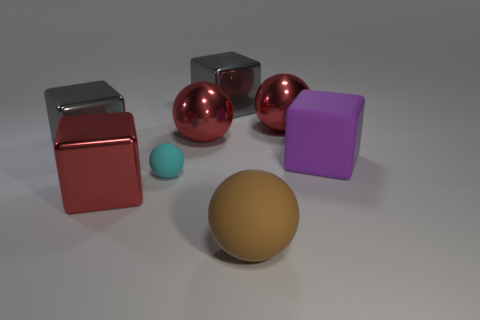What material is the purple cube that is the same size as the brown sphere?
Give a very brief answer. Rubber. The big metallic thing in front of the purple matte object is what color?
Your answer should be very brief. Red. How many metal cylinders are there?
Offer a terse response. 0. Is there a red object left of the brown ball to the right of the large red metal object that is in front of the big purple rubber block?
Offer a very short reply. Yes. What shape is the purple object that is the same size as the red metallic cube?
Offer a terse response. Cube. What number of other objects are there of the same color as the small rubber ball?
Provide a succinct answer. 0. What is the material of the red cube?
Provide a succinct answer. Metal. How many other things are the same material as the large brown thing?
Provide a short and direct response. 2. How big is the object that is in front of the small cyan thing and on the right side of the tiny thing?
Keep it short and to the point. Large. What shape is the big red object in front of the cube that is on the left side of the red block?
Offer a very short reply. Cube. 